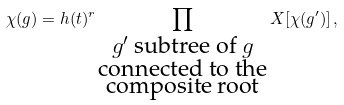Convert formula to latex. <formula><loc_0><loc_0><loc_500><loc_500>\chi ( g ) = h ( t ) ^ { r } \prod _ { \substack { \text {$g^{\prime}$ subtree of $g$} \\ \text {connected to the} \\ \text {composite root} } } X [ \chi ( g ^ { \prime } ) ] \, ,</formula> 